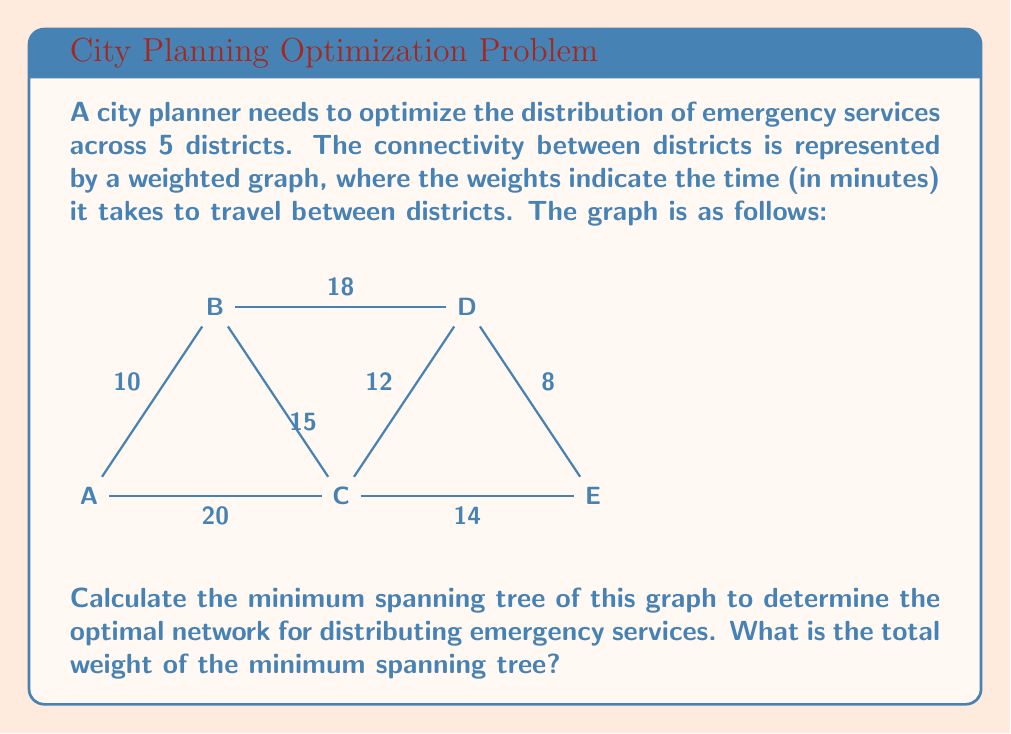Show me your answer to this math problem. To solve this problem, we'll use Kruskal's algorithm to find the minimum spanning tree (MST) of the given graph. Kruskal's algorithm works by sorting all edges by weight and then adding them to the MST one by one, skipping any edge that would create a cycle.

Step 1: Sort the edges by weight in ascending order:
1. D-E: 8
2. A-B: 10
3. C-D: 12
4. C-E: 14
5. B-C: 15
6. B-D: 18
7. A-C: 20

Step 2: Add edges to the MST, avoiding cycles:
1. Add D-E (8)
2. Add A-B (10)
3. Add C-D (12)
4. Add C-E (14) - Skip, as it would create a cycle
5. Add B-C (15)

At this point, we have connected all vertices with 4 edges, which is the required number for a spanning tree of 5 vertices (n-1 edges, where n is the number of vertices).

The resulting minimum spanning tree is:

[asy]
unitsize(1cm);

pair A = (0,0);
pair B = (2,3);
pair C = (4,0);
pair D = (6,3);
pair E = (8,0);

draw(A--B, blue);
draw(B--C, blue);
draw(C--D, blue);
draw(D--E, blue);

label("A", A, SW);
label("B", B, N);
label("C", C, S);
label("D", D, N);
label("E", E, SE);

label("10", (A+B)/2, NW);
label("15", (B+C)/2, SE);
label("12", (C+D)/2, NW);
label("8", (D+E)/2, NE);
[/asy]

Step 3: Calculate the total weight of the MST:
Total weight = 8 + 10 + 12 + 15 = 45

Therefore, the total weight of the minimum spanning tree is 45 minutes.
Answer: The total weight of the minimum spanning tree is 45 minutes. 